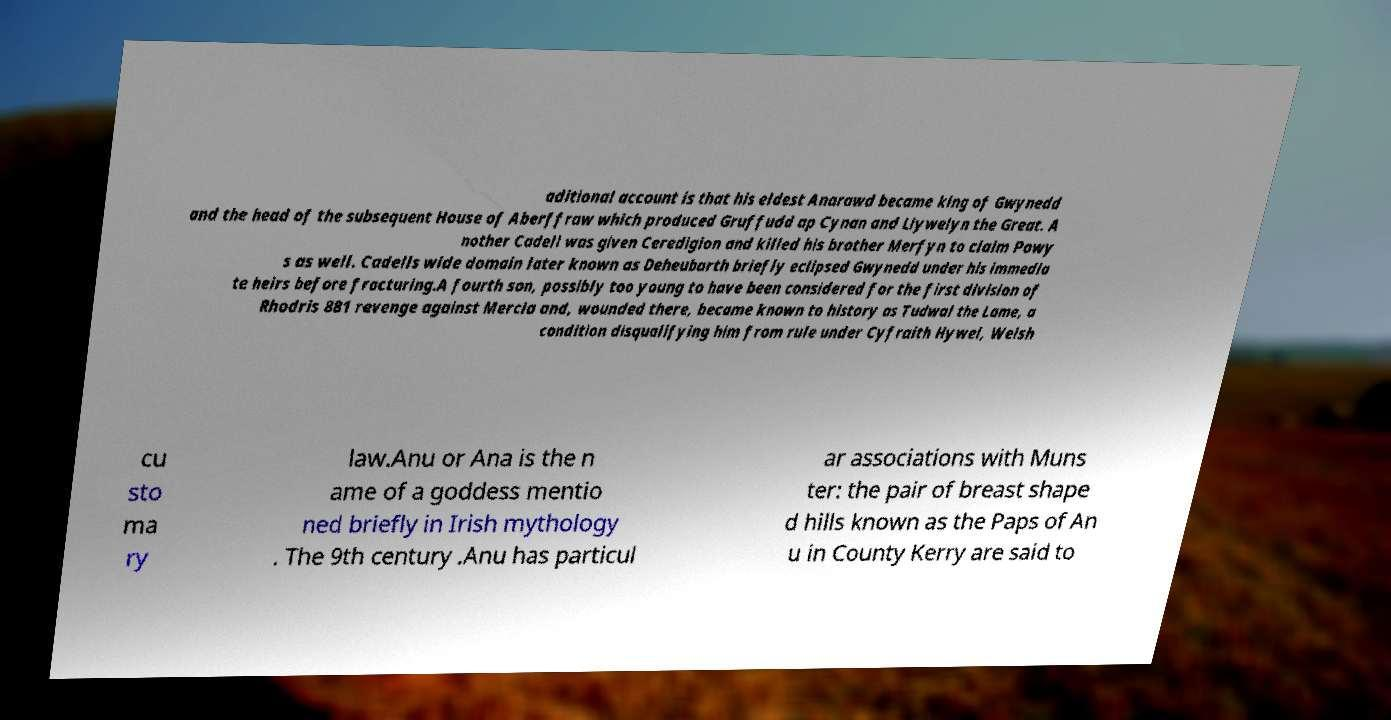What messages or text are displayed in this image? I need them in a readable, typed format. aditional account is that his eldest Anarawd became king of Gwynedd and the head of the subsequent House of Aberffraw which produced Gruffudd ap Cynan and Llywelyn the Great. A nother Cadell was given Ceredigion and killed his brother Merfyn to claim Powy s as well. Cadells wide domain later known as Deheubarth briefly eclipsed Gwynedd under his immedia te heirs before fracturing.A fourth son, possibly too young to have been considered for the first division of Rhodris 881 revenge against Mercia and, wounded there, became known to history as Tudwal the Lame, a condition disqualifying him from rule under Cyfraith Hywel, Welsh cu sto ma ry law.Anu or Ana is the n ame of a goddess mentio ned briefly in Irish mythology . The 9th century .Anu has particul ar associations with Muns ter: the pair of breast shape d hills known as the Paps of An u in County Kerry are said to 